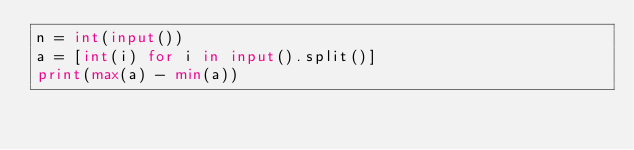<code> <loc_0><loc_0><loc_500><loc_500><_Python_>n = int(input())
a = [int(i) for i in input().split()]
print(max(a) - min(a))</code> 